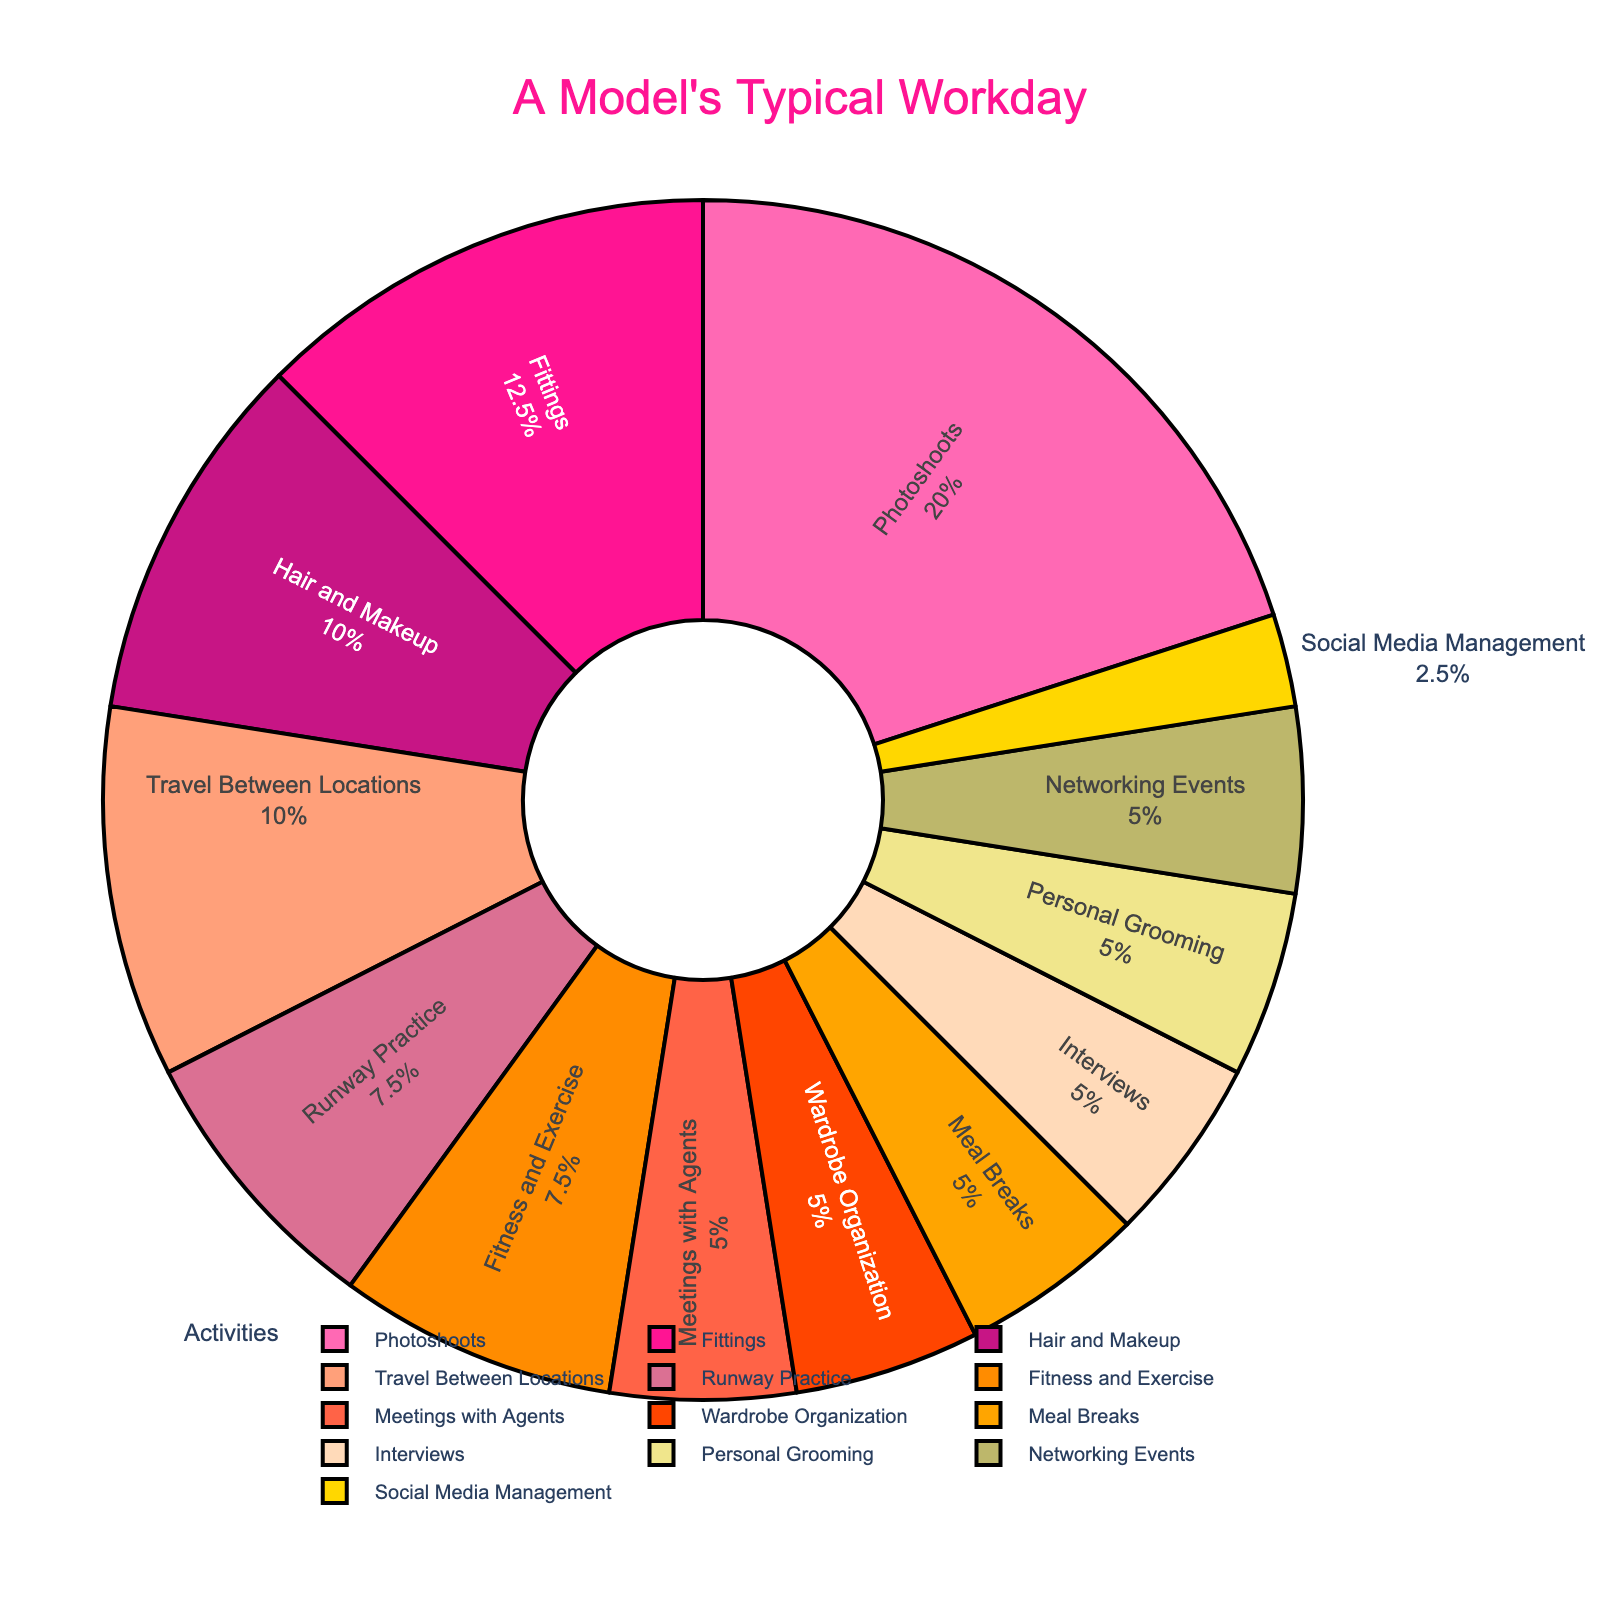What's the total time spent on Photoshoots and Travel Between Locations? To find the total time spent on Photoshoots and Travel Between Locations, simply add the hours allocated to each activity: Photoshoots (4 hours) + Travel Between Locations (2 hours) = 6 hours
Answer: 6 hours Which activity takes up the most time in a model's typical workday? From the pie chart, the largest section represents Photoshoots, indicating it takes up the most time in the workday, which is 4 hours
Answer: Photoshoots How much more time is spent on Fittings compared to Personal Grooming? To find the difference in time spent between Fittings and Personal Grooming, subtract the hours allocated to Personal Grooming from the hours allocated to Fittings: Fittings (2.5 hours) - Personal Grooming (1 hour) = 1.5 hours
Answer: 1.5 hours Does a model spend more time on Runway Practice or Fitness and Exercise? From the pie chart, it is clear that Fitness and Exercise takes up 1.5 hours, whereas Runway Practice takes up 1.5 hours. By comparison, both activities take the same amount of time in a model's typical workday.
Answer: Both activities take the same amount of time Which activity has the smallest percentage of time allocation? By examining the pie chart, Social Media Management occupies the smallest segment, indicating it has the smallest percentage of time allocation, which is 0.5 hours
Answer: Social Media Management Calculate the combined percentage of time spent on Meetings with Agents and Interviews. To calculate the combined percentage, we first sum the hours allocated to these activities: Meetings with Agents (1 hour) + Interviews (1 hour) = 2 hours. The total time is 20 hours. So, (2 / 20) * 100 = 10%
Answer: 10% Is more time spent on Meals Breaks or Hair and Makeup? By looking at the pie chart, more time is spent on Hair and Makeup (2 hours) compared to Meal Breaks (1 hour)
Answer: Hair and Makeup Combine the time spent on Wardrobe Organization, Meal Breaks, and Networking Events. What's the total? Sum the hours allocated to these activities: Wardrobe Organization (1 hour) + Meal Breaks (1 hour) + Networking Events (1 hour) = 3 hours
Answer: 3 hours If you sum the times spent on activities related to appearances (Hair and Makeup, Personal Grooming, and Wardrobe Organization), what do you get? The sum is Hair and Makeup (2 hours) + Personal Grooming (1 hour) + Wardrobe Organization (1 hour) = 4 hours
Answer: 4 hours 